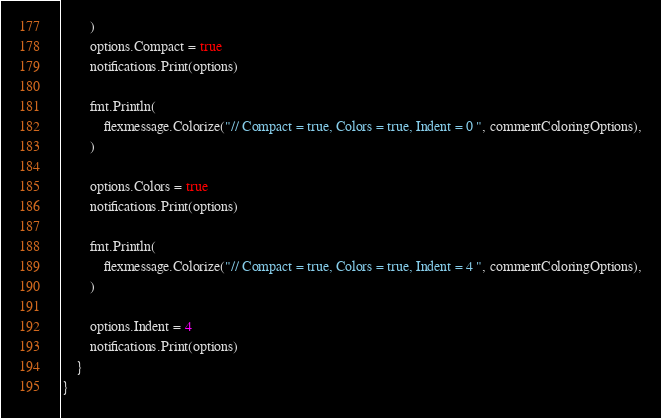<code> <loc_0><loc_0><loc_500><loc_500><_Go_>		)
		options.Compact = true
		notifications.Print(options)

		fmt.Println(
			flexmessage.Colorize("// Compact = true, Colors = true, Indent = 0 ", commentColoringOptions),
		)

		options.Colors = true
		notifications.Print(options)

		fmt.Println(
			flexmessage.Colorize("// Compact = true, Colors = true, Indent = 4 ", commentColoringOptions),
		)

		options.Indent = 4
		notifications.Print(options)
	}
}
</code> 